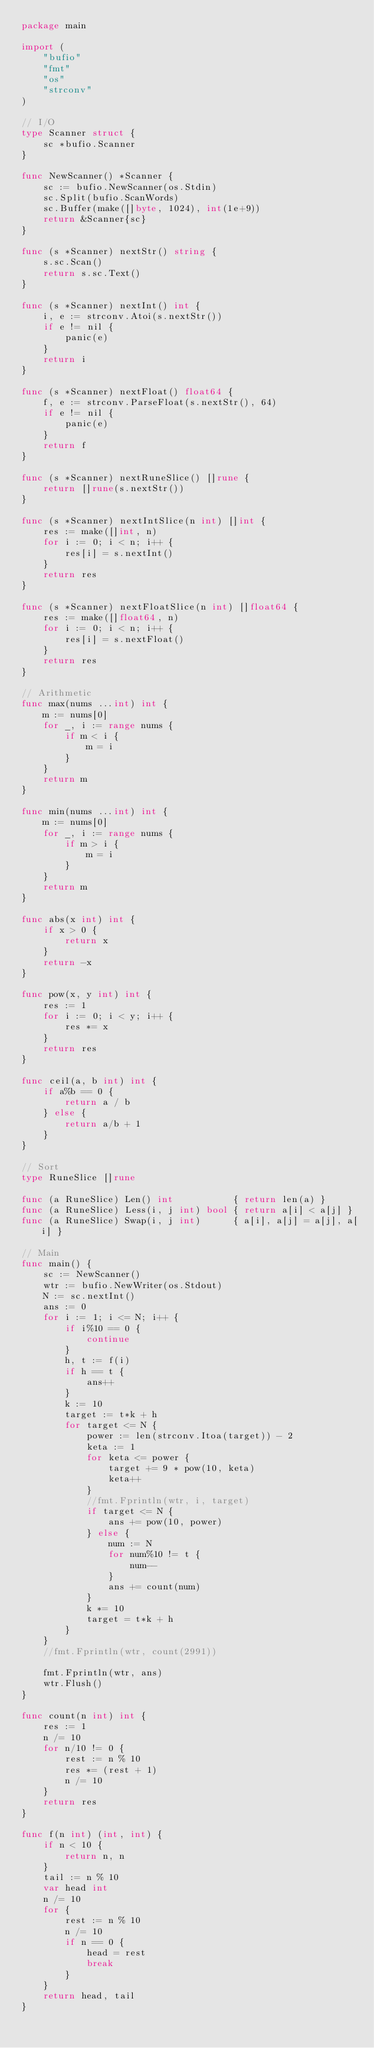Convert code to text. <code><loc_0><loc_0><loc_500><loc_500><_Go_>package main

import (
	"bufio"
	"fmt"
	"os"
	"strconv"
)

// I/O
type Scanner struct {
	sc *bufio.Scanner
}

func NewScanner() *Scanner {
	sc := bufio.NewScanner(os.Stdin)
	sc.Split(bufio.ScanWords)
	sc.Buffer(make([]byte, 1024), int(1e+9))
	return &Scanner{sc}
}

func (s *Scanner) nextStr() string {
	s.sc.Scan()
	return s.sc.Text()
}

func (s *Scanner) nextInt() int {
	i, e := strconv.Atoi(s.nextStr())
	if e != nil {
		panic(e)
	}
	return i
}

func (s *Scanner) nextFloat() float64 {
	f, e := strconv.ParseFloat(s.nextStr(), 64)
	if e != nil {
		panic(e)
	}
	return f
}

func (s *Scanner) nextRuneSlice() []rune {
	return []rune(s.nextStr())
}

func (s *Scanner) nextIntSlice(n int) []int {
	res := make([]int, n)
	for i := 0; i < n; i++ {
		res[i] = s.nextInt()
	}
	return res
}

func (s *Scanner) nextFloatSlice(n int) []float64 {
	res := make([]float64, n)
	for i := 0; i < n; i++ {
		res[i] = s.nextFloat()
	}
	return res
}

// Arithmetic
func max(nums ...int) int {
	m := nums[0]
	for _, i := range nums {
		if m < i {
			m = i
		}
	}
	return m
}

func min(nums ...int) int {
	m := nums[0]
	for _, i := range nums {
		if m > i {
			m = i
		}
	}
	return m
}

func abs(x int) int {
	if x > 0 {
		return x
	}
	return -x
}

func pow(x, y int) int {
	res := 1
	for i := 0; i < y; i++ {
		res *= x
	}
	return res
}

func ceil(a, b int) int {
	if a%b == 0 {
		return a / b
	} else {
		return a/b + 1
	}
}

// Sort
type RuneSlice []rune

func (a RuneSlice) Len() int           { return len(a) }
func (a RuneSlice) Less(i, j int) bool { return a[i] < a[j] }
func (a RuneSlice) Swap(i, j int)      { a[i], a[j] = a[j], a[i] }

// Main
func main() {
	sc := NewScanner()
	wtr := bufio.NewWriter(os.Stdout)
	N := sc.nextInt()
	ans := 0
	for i := 1; i <= N; i++ {
		if i%10 == 0 {
			continue
		}
		h, t := f(i)
		if h == t {
			ans++
		}
		k := 10
		target := t*k + h
		for target <= N {
			power := len(strconv.Itoa(target)) - 2
			keta := 1
			for keta <= power {
				target += 9 * pow(10, keta)
				keta++
			}
			//fmt.Fprintln(wtr, i, target)
			if target <= N {
				ans += pow(10, power)
			} else {
				num := N
				for num%10 != t {
					num--
				}
				ans += count(num)
			}
			k *= 10
			target = t*k + h
		}
	}
	//fmt.Fprintln(wtr, count(2991))

	fmt.Fprintln(wtr, ans)
	wtr.Flush()
}

func count(n int) int {
	res := 1
	n /= 10
	for n/10 != 0 {
		rest := n % 10
		res *= (rest + 1)
		n /= 10
	}
	return res
}

func f(n int) (int, int) {
	if n < 10 {
		return n, n
	}
	tail := n % 10
	var head int
	n /= 10
	for {
		rest := n % 10
		n /= 10
		if n == 0 {
			head = rest
			break
		}
	}
	return head, tail
}
</code> 